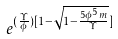Convert formula to latex. <formula><loc_0><loc_0><loc_500><loc_500>e ^ { ( \frac { \Upsilon } { \phi } ) [ 1 - \sqrt { 1 - \frac { 5 \phi ^ { 5 } m } { \Upsilon } } ] }</formula> 